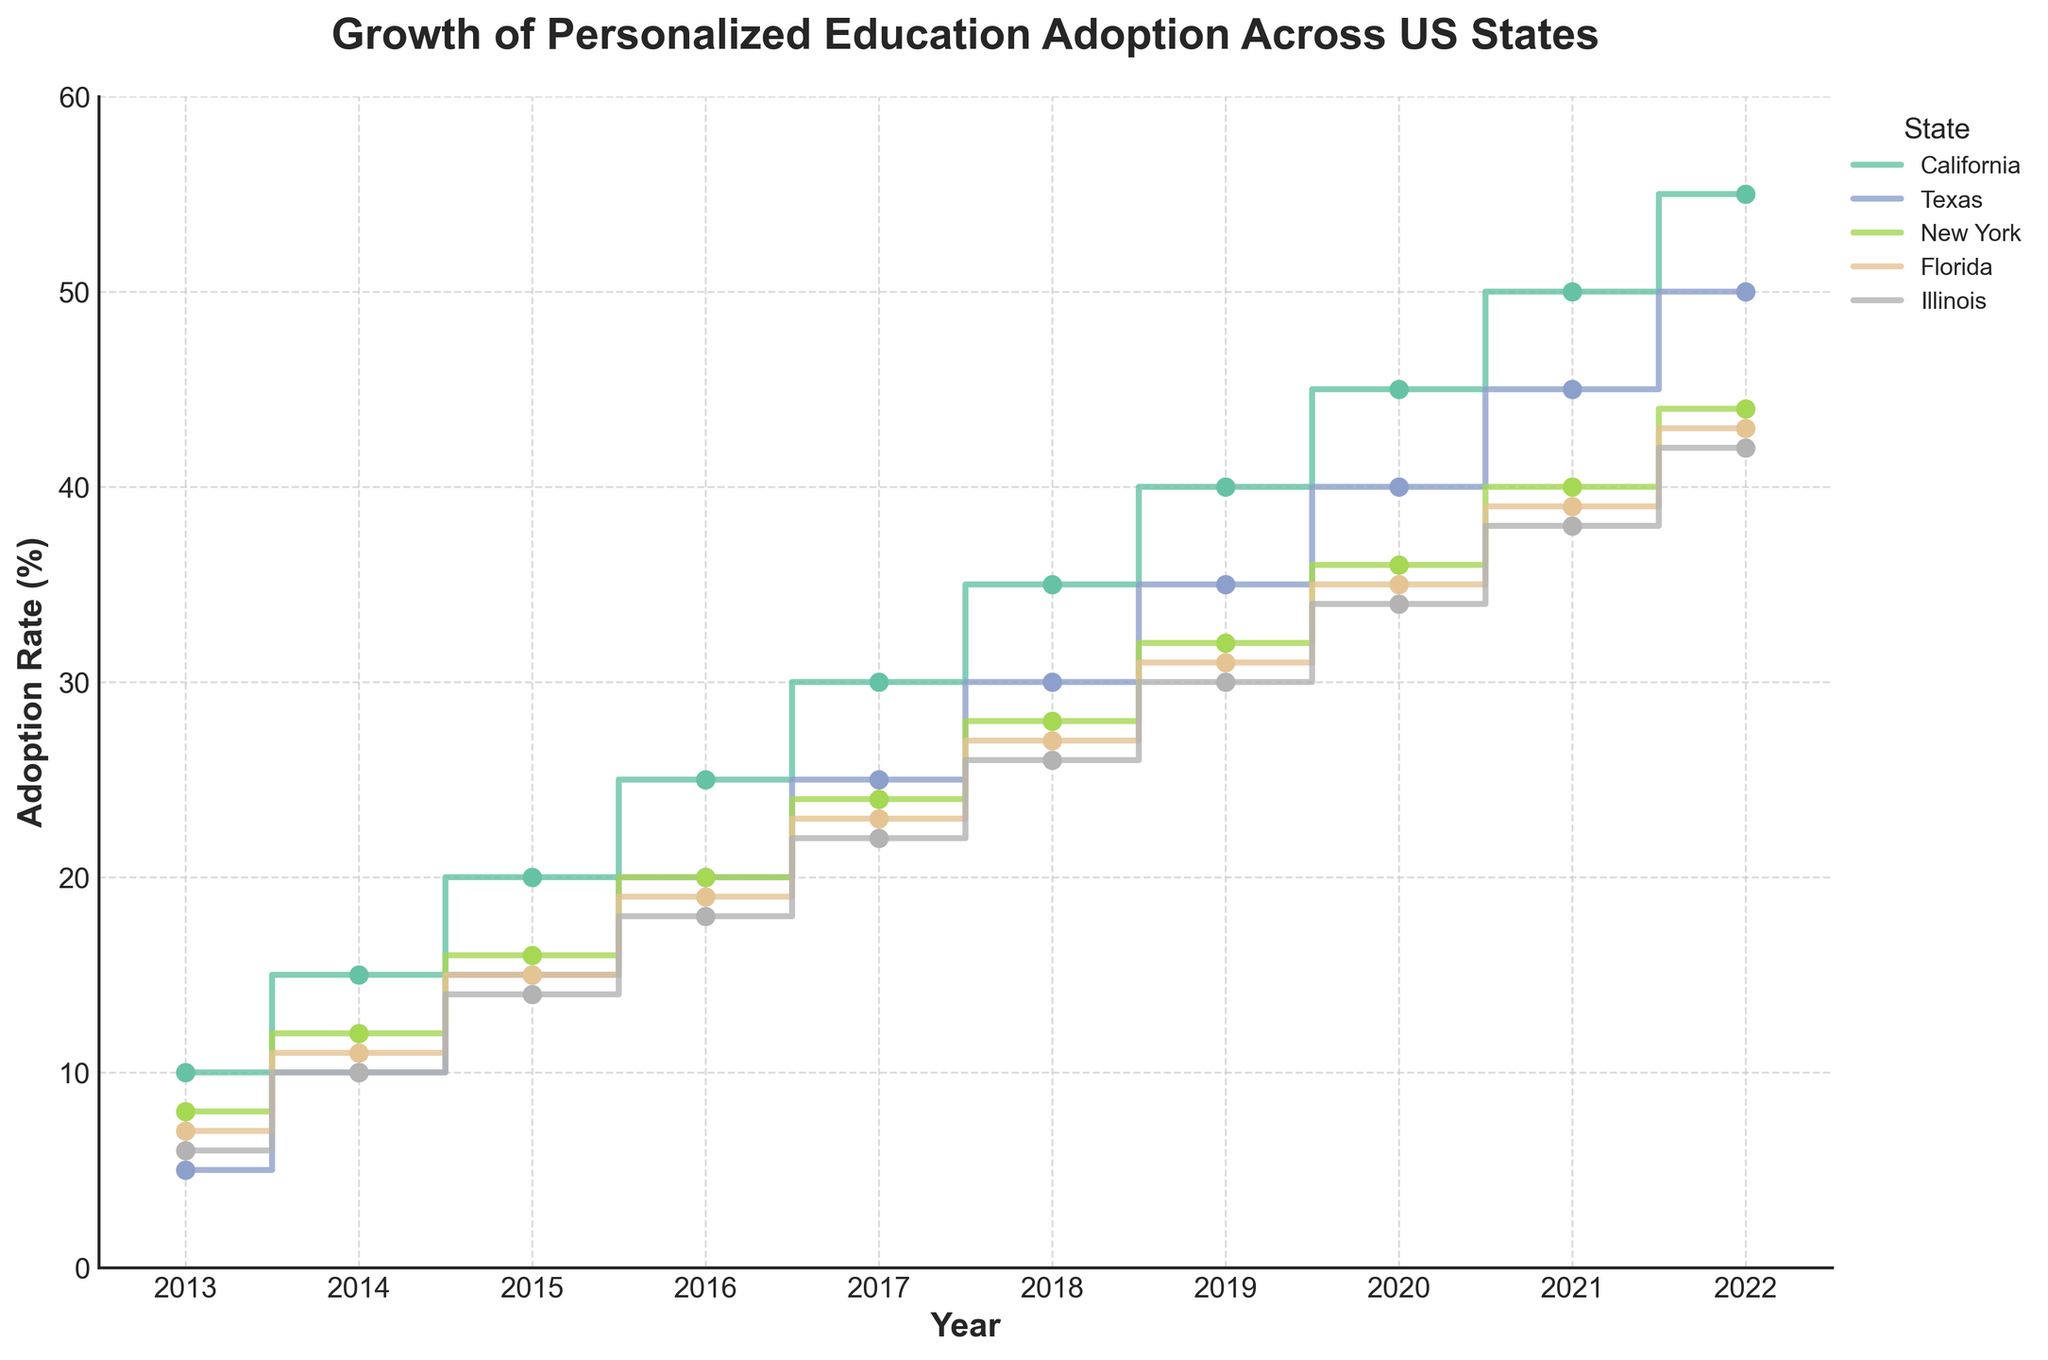What's the title of the figure? The title of the figure is usually located at the top center of the plot and is set to provide an overview of what the figure represents. In this case, the title given in the code is "Growth of Personalized Education Adoption Across US States".
Answer: Growth of Personalized Education Adoption Across US States Which state had the highest adoption rate of personalized education in 2022? The highest adoption rates for different states in 2022 can be seen at the end of each state's line. California reaches 55% in 2022, which is higher compared to other states like Texas (50%), New York (44%), Florida (43%), and Illinois (42%). So, California had the highest adoption rate in 2022.
Answer: California How did Texas' adoption rate change from 2014 to 2018? To determine the change in adoption rate for Texas from 2014 to 2018, look at the step plot for Texas in those years and note the values. The adoption rate in Texas increased from 10% in 2014 to 30% in 2018. The change, therefore, is 30% - 10% = 20%.
Answer: Increased by 20% What's the average adoption rate of personalized education in New York over the decade? To find the average, sum up New York's adoption rates from 2013 to 2022 (8, 12, 16, 20, 24, 28, 32, 36, 40, 44) and divide by the number of years (10). The sum is 8+12+16+20+24+28+32+36+40+44 = 260. The average is 260 / 10 = 26%.
Answer: 26% Which state experienced a continuous yearly increase in their adoption rate from 2013 to 2022? To determine this, check each state's plot line for a consistent upward step increase from year to year without any declines. From the data, California (10, 15, 20, 25, 30, 35, 40, 45, 50, 55), Texas (5, 10, 15, 20, 25, 30, 35, 40, 45, 50), New York (8, 12, 16, 20, 24, 28, 32, 36, 40, 44), Florida (7, 11, 15, 19, 23, 27, 31, 35, 39, 43), and Illinois (6, 10, 14, 18, 22, 26, 30, 34, 38, 42) all show continuous yearly increases.
Answer: California, Texas, New York, Florida, Illinois In which year did Illinois have an adoption rate of 30%? Look at the step line for Illinois and identify the year corresponding to the 30% mark. The adoption rate for Illinois is 30% in the year 2019.
Answer: 2019 Compare the adoption rates of personalized education between Florida and New York in 2017. Identify the adoption rates from the plot for Florida and New York in 2017. In 2017, Florida's adoption rate was 23%, and New York's was 24%.
Answer: Florida: 23%, New York: 24% What is the overall trend observed in the adoption rates across all states over the last decade? The overall trend can be observed by looking at the general direction of the step lines for the states from 2013 to 2022. All states show a steady and consistent increase in the adoption rates, indicating a broad trend of increasing adoption of personalized education across the decade.
Answer: Increasing trend 